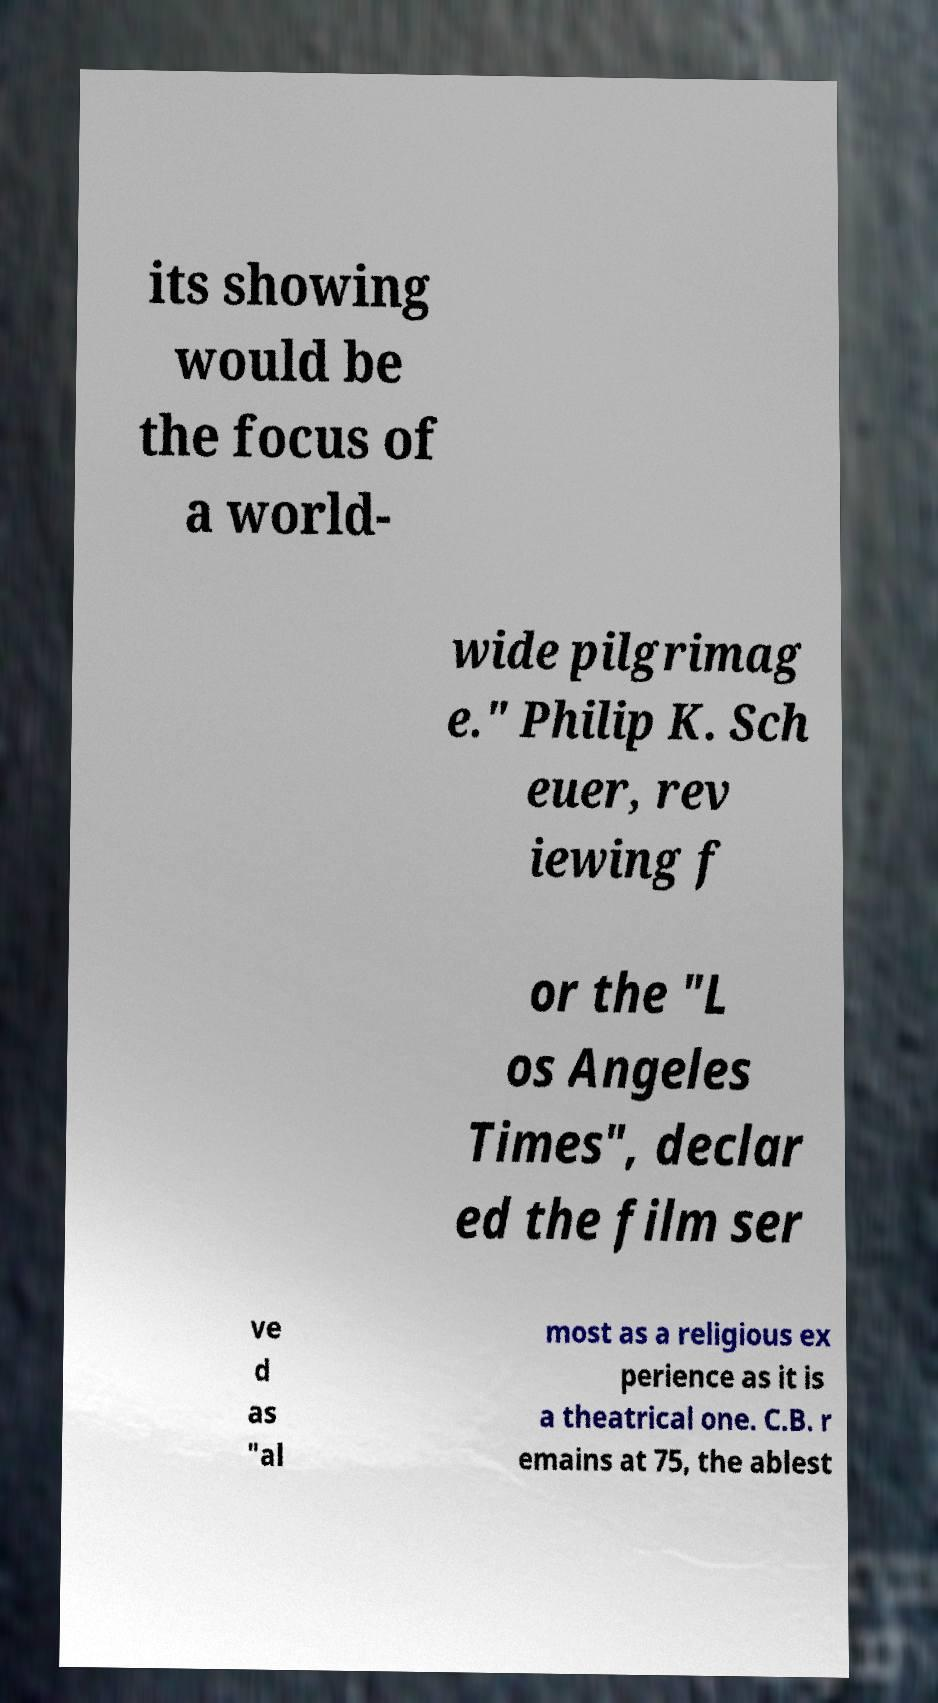Could you extract and type out the text from this image? its showing would be the focus of a world- wide pilgrimag e." Philip K. Sch euer, rev iewing f or the "L os Angeles Times", declar ed the film ser ve d as "al most as a religious ex perience as it is a theatrical one. C.B. r emains at 75, the ablest 